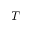<formula> <loc_0><loc_0><loc_500><loc_500>T</formula> 